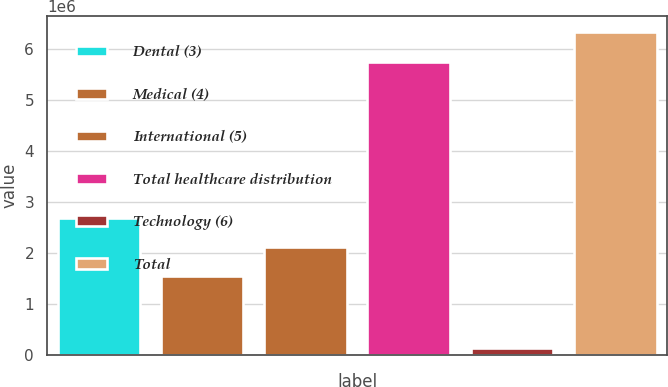Convert chart to OTSL. <chart><loc_0><loc_0><loc_500><loc_500><bar_chart><fcel>Dental (3)<fcel>Medical (4)<fcel>International (5)<fcel>Total healthcare distribution<fcel>Technology (6)<fcel>Total<nl><fcel>2.69187e+06<fcel>1.54027e+06<fcel>2.11607e+06<fcel>5.75799e+06<fcel>131893<fcel>6.33379e+06<nl></chart> 